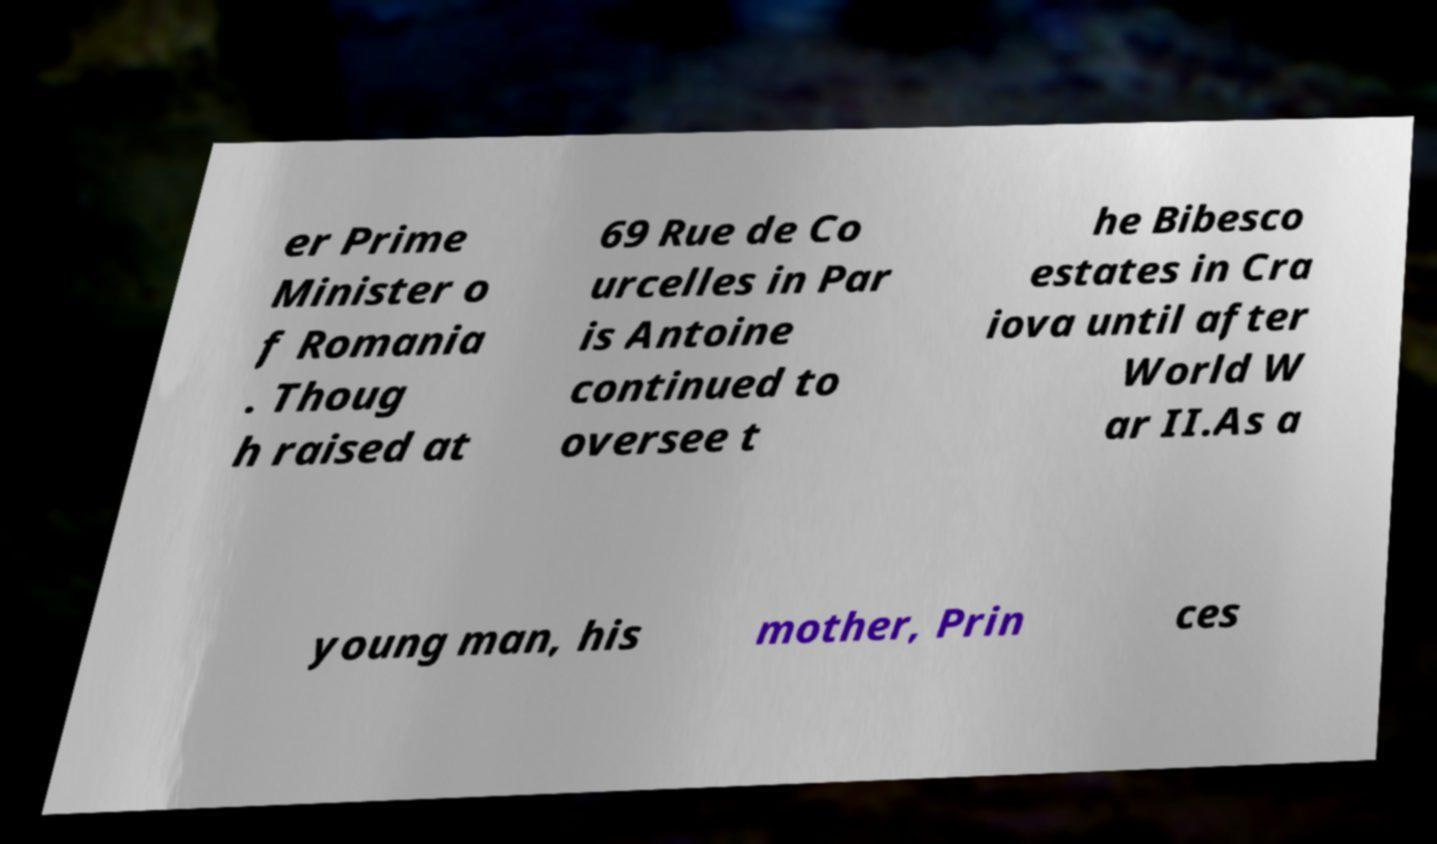I need the written content from this picture converted into text. Can you do that? er Prime Minister o f Romania . Thoug h raised at 69 Rue de Co urcelles in Par is Antoine continued to oversee t he Bibesco estates in Cra iova until after World W ar II.As a young man, his mother, Prin ces 